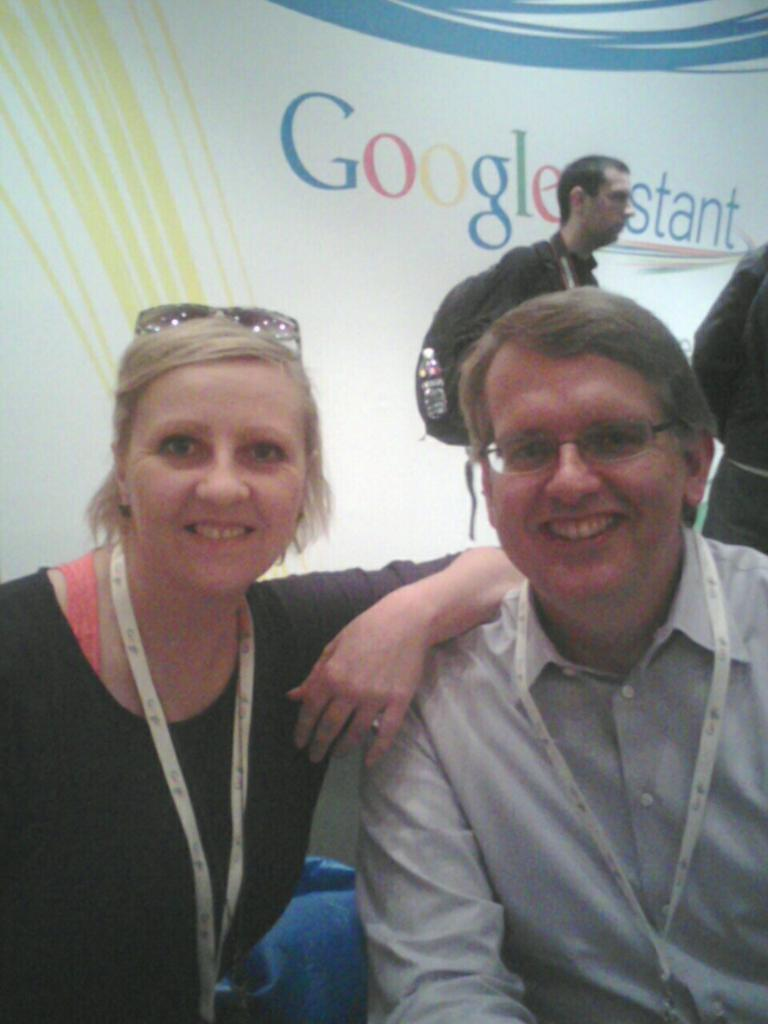How many people are visible in the image? There are two people sitting in the image. Are there any other people in the image besides the two sitting? Yes, there are two people standing in the background of the image. What can be seen hanging or displayed in the image? There is a banner in the image. What is written or depicted on the banner? There is text on the banner. Can you see any cows in the image? No, there are no cows present in the image. What type of surprise is being celebrated with the banner in the image? The image does not provide any information about a surprise or celebration; it only shows the presence of a banner with text. 